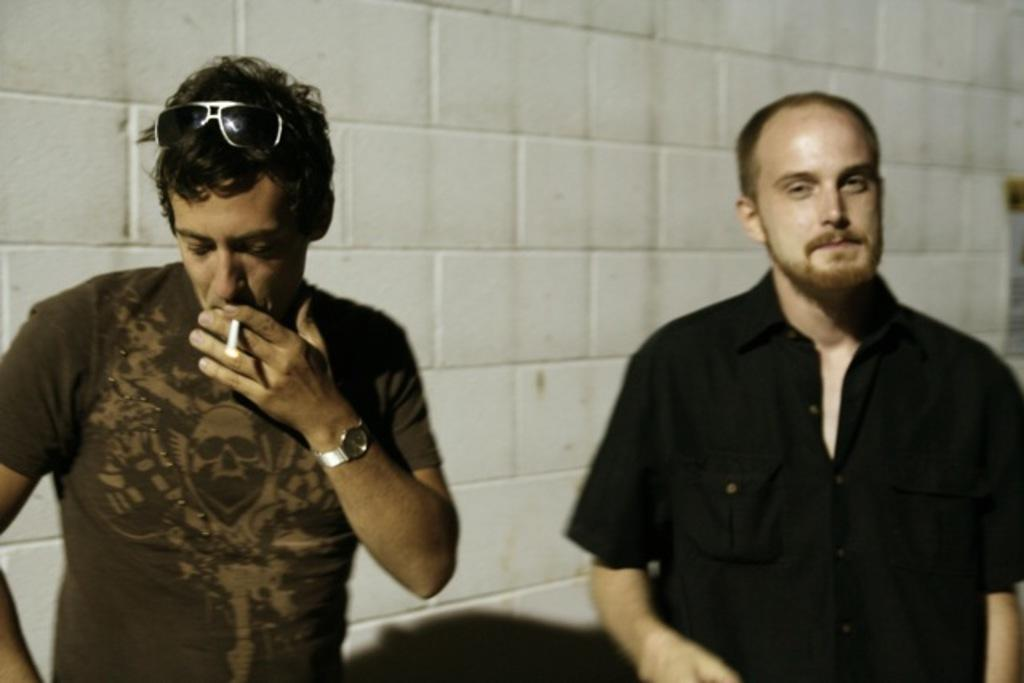What is the man in the black shirt wearing in the image? The man in the black shirt is wearing a black shirt in the image. Where is the man in the black shirt located in the image? The man in the black shirt is standing on the right side in the image. What is the man in the t-shirt doing in the image? The man in the t-shirt is smoking a cigarette in the image. Where is the man in the t-shirt located in the image? The man in the t-shirt is on the left side in the image. What is visible behind the men in the image? There is a wall visible behind the men in the image. How much money is the man in the t-shirt carrying in the image? There is no indication of money or any financial transactions in the image. What type of bag is the man in the black shirt holding in the image? There is no bag visible in the image. 